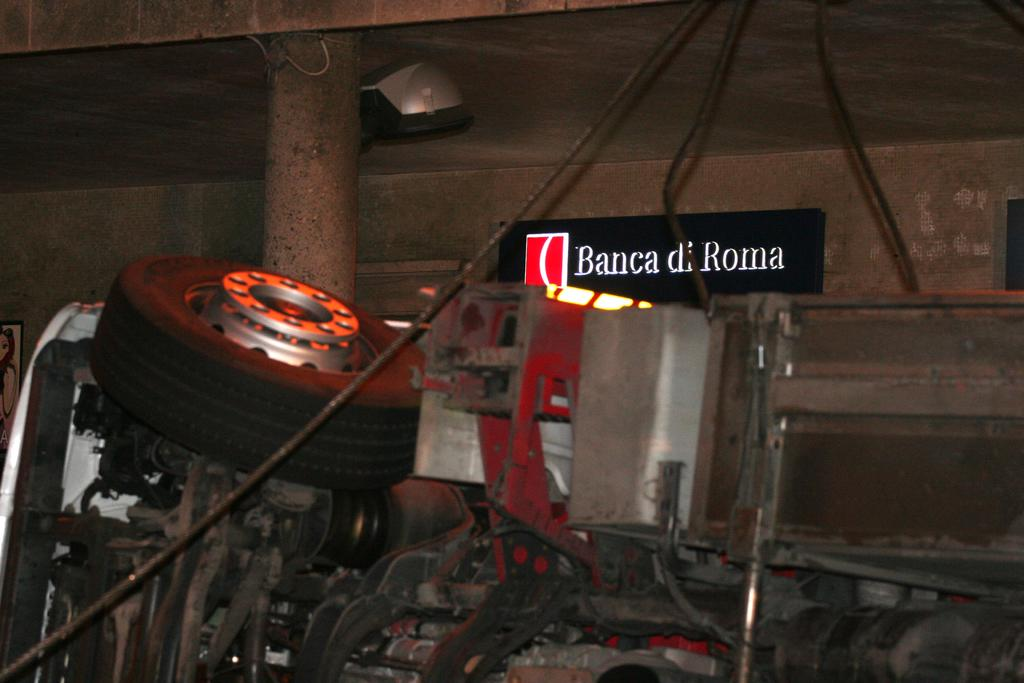What is the main object in the picture? There is a machine in the picture. What feature can be seen on the left side of the machine? There is a wheel on the left side of the machine. What is located behind the machine? There is a wall behind the machine. Is there any text or label visible in the image? Yes, there is a name plate attached to the wall. How many screws can be seen holding the bit in place in the image? There is no bit or screws present in the image; it features a machine with a wheel on the left side and a name plate on the wall. What type of ticket is visible on the machine in the image? There is no ticket present in the image; it features a machine with a wheel on the left side and a name plate on the wall. 